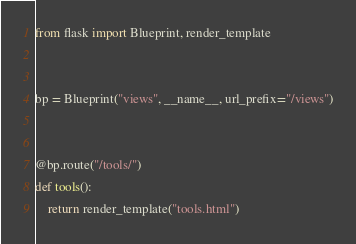Convert code to text. <code><loc_0><loc_0><loc_500><loc_500><_Python_>from flask import Blueprint, render_template


bp = Blueprint("views", __name__, url_prefix="/views")


@bp.route("/tools/")
def tools():
    return render_template("tools.html")
</code> 